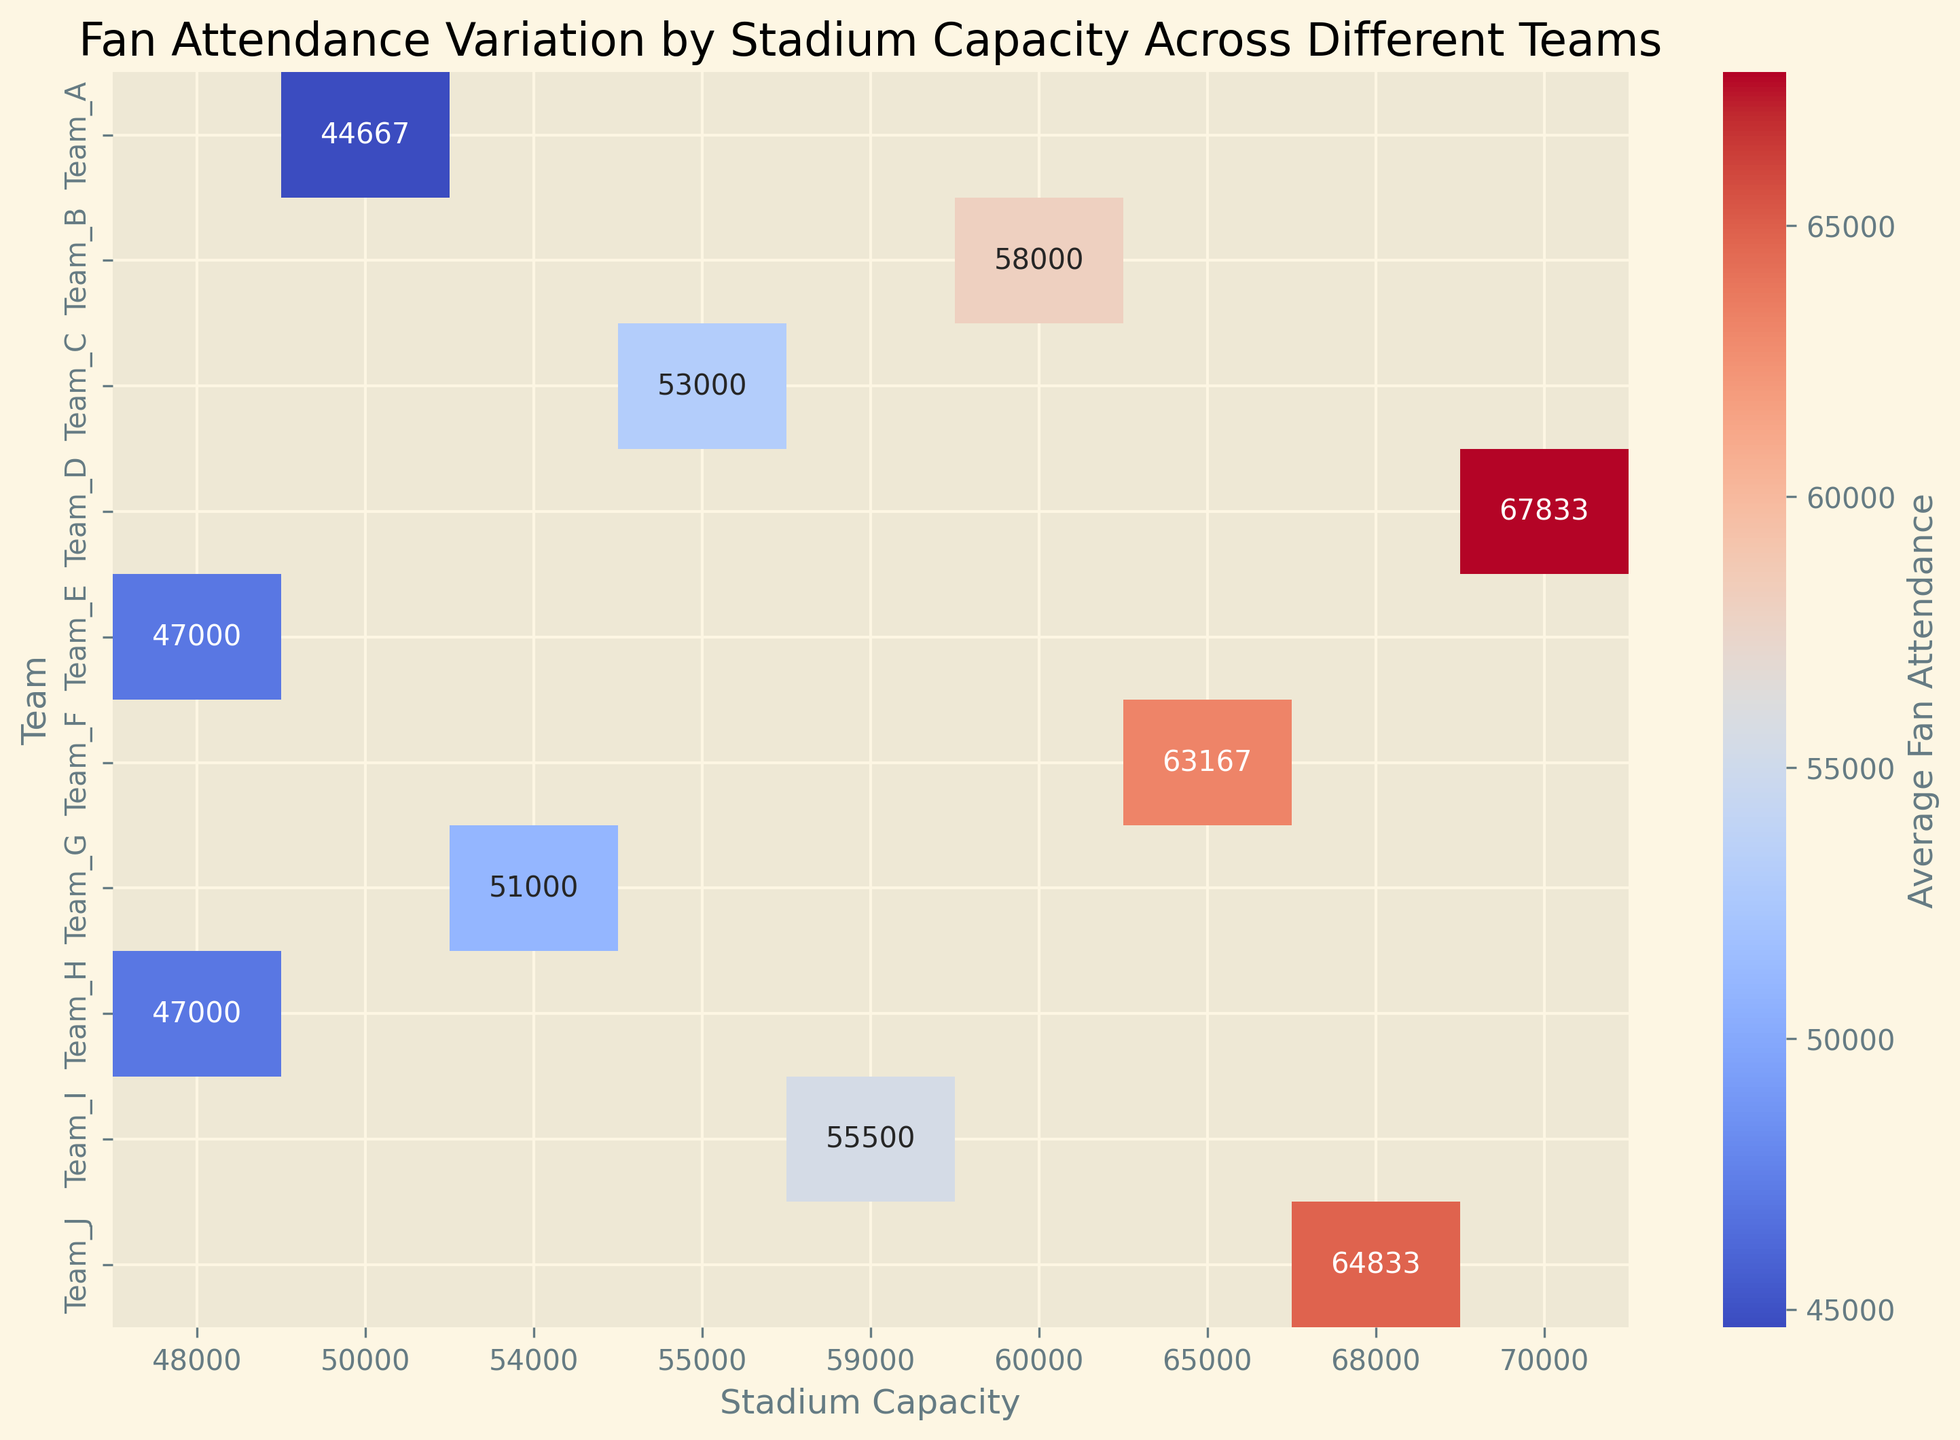Which team has the highest average fan attendance? From the heatmap, Team_D consistently shows the highest average fan attendance across its stadium capacity.
Answer: Team_D Which team has the largest variance in fan attendance? The variance can be observed by the range of attendance values in the heatmap. Team_A has significant variation in attendance across the same stadium capacity.
Answer: Team_A Which teams have the same stadium capacity but different average fan attendance levels? Teams E and H both have a stadium capacity of 48,000 but have variations in their fan attendance values.
Answer: Teams E and H How does Team_B's average attendance compare to Team_C's? By examining their respective values in the heatmap, Team_B has higher average attendance compared to Team_C.
Answer: Team_B has higher average attendance Which team has the lowest average attendance in the 54,000-capacity stadiums? Looking across the column for 54,000-capacity stadiums, Team_G has the lowest attendance.
Answer: Team_G What is the difference between the highest and lowest average attendance? The highest average attendance is for Team_D (around 68,000), and the lowest is for Team_H (around 46,500). The difference is 68,000 - 46,500 = 21,500.
Answer: 21,500 Is there a team with attendance consistently close to the stadium's capacity? Team_B's attendance values are close to its stadium capacity of 60,000.
Answer: Team_B Which team has the fan attendance closest to 55,000 on average? Team_I's fan attendance is closest to 55,000 based on the heatmap.
Answer: Team_I What is the average stadium capacity for teams with fan attendance above 60,000? Teams with attendance above 60,000 include Team_D, Team_J, and Team_F. Their stadium capacities are 70,000, 68,000, and 65,000 respectively. The average capacity is (70,000 + 68,000 + 65,000) / 3 = 67,666.67.
Answer: 67,666.67 